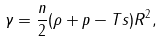<formula> <loc_0><loc_0><loc_500><loc_500>\gamma = \frac { n } { 2 } ( \rho + p - T s ) R ^ { 2 } ,</formula> 